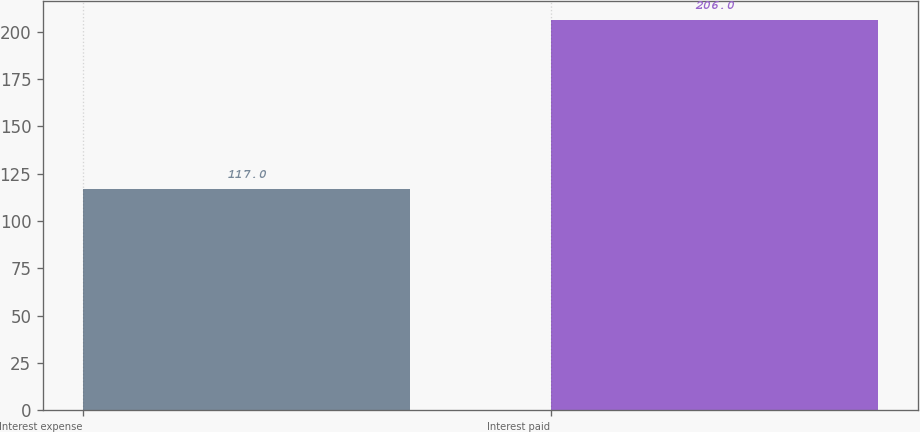<chart> <loc_0><loc_0><loc_500><loc_500><bar_chart><fcel>Interest expense<fcel>Interest paid<nl><fcel>117<fcel>206<nl></chart> 